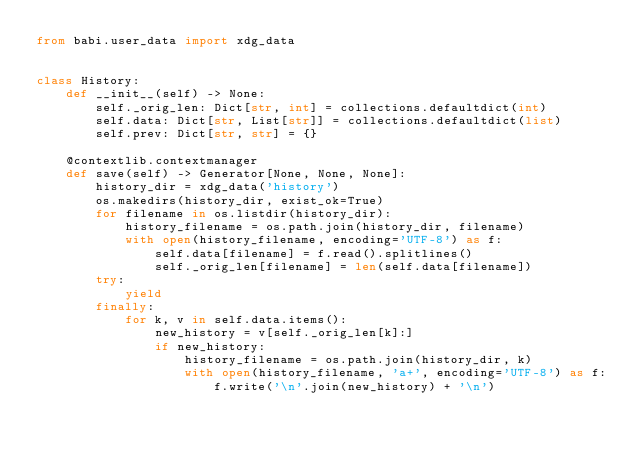Convert code to text. <code><loc_0><loc_0><loc_500><loc_500><_Python_>from babi.user_data import xdg_data


class History:
    def __init__(self) -> None:
        self._orig_len: Dict[str, int] = collections.defaultdict(int)
        self.data: Dict[str, List[str]] = collections.defaultdict(list)
        self.prev: Dict[str, str] = {}

    @contextlib.contextmanager
    def save(self) -> Generator[None, None, None]:
        history_dir = xdg_data('history')
        os.makedirs(history_dir, exist_ok=True)
        for filename in os.listdir(history_dir):
            history_filename = os.path.join(history_dir, filename)
            with open(history_filename, encoding='UTF-8') as f:
                self.data[filename] = f.read().splitlines()
                self._orig_len[filename] = len(self.data[filename])
        try:
            yield
        finally:
            for k, v in self.data.items():
                new_history = v[self._orig_len[k]:]
                if new_history:
                    history_filename = os.path.join(history_dir, k)
                    with open(history_filename, 'a+', encoding='UTF-8') as f:
                        f.write('\n'.join(new_history) + '\n')
</code> 